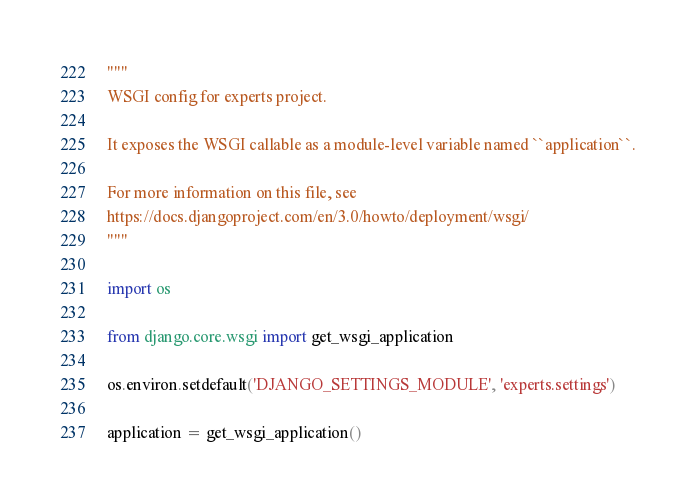Convert code to text. <code><loc_0><loc_0><loc_500><loc_500><_Python_>"""
WSGI config for experts project.

It exposes the WSGI callable as a module-level variable named ``application``.

For more information on this file, see
https://docs.djangoproject.com/en/3.0/howto/deployment/wsgi/
"""

import os

from django.core.wsgi import get_wsgi_application

os.environ.setdefault('DJANGO_SETTINGS_MODULE', 'experts.settings')

application = get_wsgi_application()
</code> 